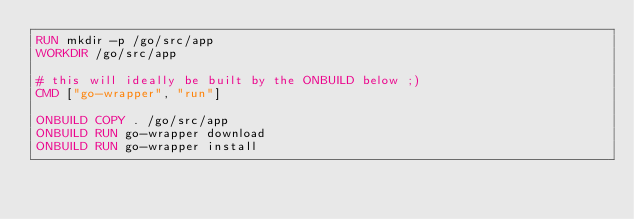Convert code to text. <code><loc_0><loc_0><loc_500><loc_500><_Dockerfile_>RUN mkdir -p /go/src/app
WORKDIR /go/src/app

# this will ideally be built by the ONBUILD below ;)
CMD ["go-wrapper", "run"]

ONBUILD COPY . /go/src/app
ONBUILD RUN go-wrapper download
ONBUILD RUN go-wrapper install
</code> 